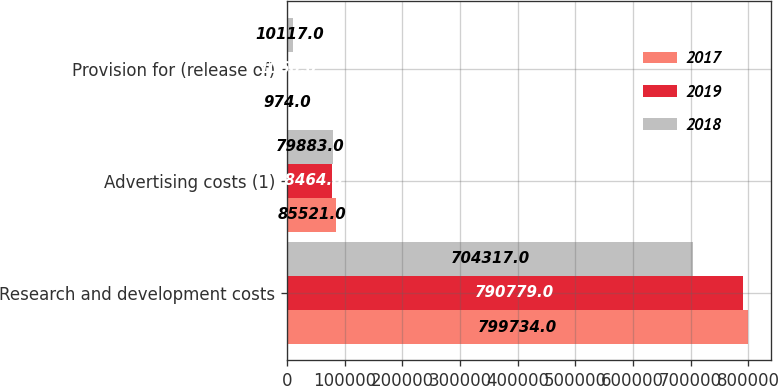<chart> <loc_0><loc_0><loc_500><loc_500><stacked_bar_chart><ecel><fcel>Research and development costs<fcel>Advertising costs (1)<fcel>Provision for (release of)<nl><fcel>2017<fcel>799734<fcel>85521<fcel>974<nl><fcel>2019<fcel>790779<fcel>78464<fcel>1060<nl><fcel>2018<fcel>704317<fcel>79883<fcel>10117<nl></chart> 